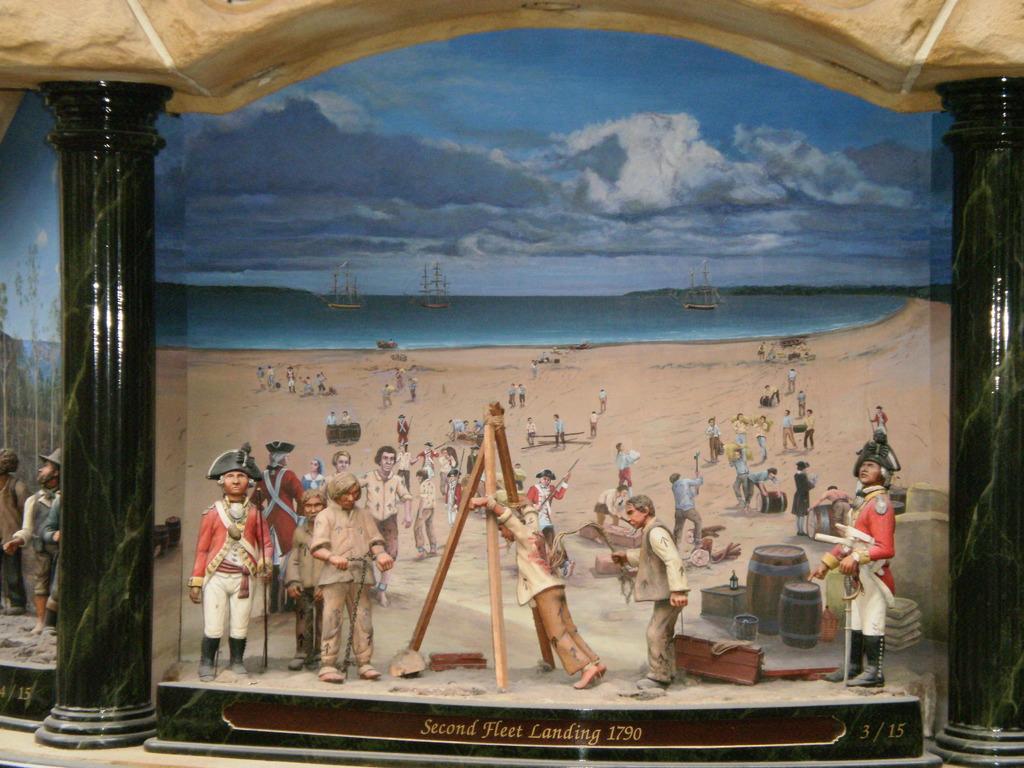What year is depicted here?
Provide a short and direct response. 1790. What year was this painting completed?
Provide a short and direct response. 1790. 